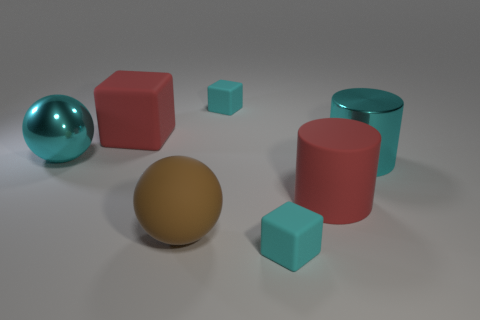What shape is the shiny thing that is the same color as the large shiny cylinder?
Your answer should be very brief. Sphere. What is the color of the large metal cylinder?
Your response must be concise. Cyan. Do the shiny thing left of the large brown matte ball and the big brown rubber object have the same shape?
Give a very brief answer. Yes. How many objects are big cyan things on the right side of the brown thing or big cylinders?
Offer a very short reply. 2. Is there a large red matte object of the same shape as the brown thing?
Keep it short and to the point. No. What is the shape of the brown object that is the same size as the red rubber cylinder?
Keep it short and to the point. Sphere. What shape is the object to the left of the matte block that is left of the big sphere right of the metal sphere?
Keep it short and to the point. Sphere. Is the shape of the big brown thing the same as the big cyan thing that is to the left of the big cyan metal cylinder?
Your response must be concise. Yes. What number of large objects are cylinders or cyan metallic things?
Your answer should be compact. 3. Are there any red objects that have the same size as the red matte cube?
Provide a short and direct response. Yes. 